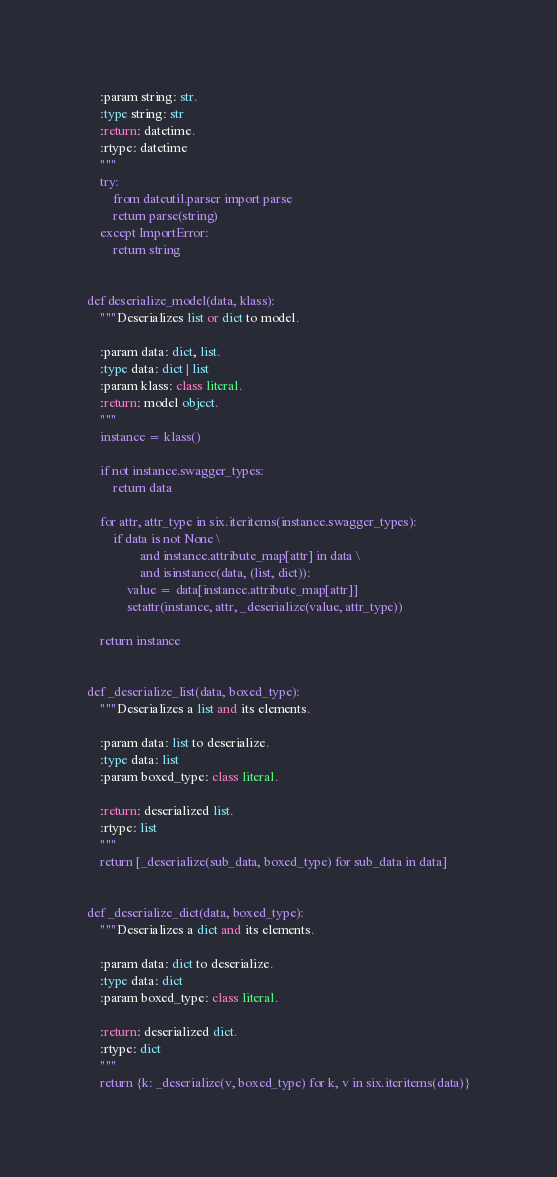<code> <loc_0><loc_0><loc_500><loc_500><_Python_>
    :param string: str.
    :type string: str
    :return: datetime.
    :rtype: datetime
    """
    try:
        from dateutil.parser import parse
        return parse(string)
    except ImportError:
        return string


def deserialize_model(data, klass):
    """Deserializes list or dict to model.

    :param data: dict, list.
    :type data: dict | list
    :param klass: class literal.
    :return: model object.
    """
    instance = klass()

    if not instance.swagger_types:
        return data

    for attr, attr_type in six.iteritems(instance.swagger_types):
        if data is not None \
                and instance.attribute_map[attr] in data \
                and isinstance(data, (list, dict)):
            value = data[instance.attribute_map[attr]]
            setattr(instance, attr, _deserialize(value, attr_type))

    return instance


def _deserialize_list(data, boxed_type):
    """Deserializes a list and its elements.

    :param data: list to deserialize.
    :type data: list
    :param boxed_type: class literal.

    :return: deserialized list.
    :rtype: list
    """
    return [_deserialize(sub_data, boxed_type) for sub_data in data]


def _deserialize_dict(data, boxed_type):
    """Deserializes a dict and its elements.

    :param data: dict to deserialize.
    :type data: dict
    :param boxed_type: class literal.

    :return: deserialized dict.
    :rtype: dict
    """
    return {k: _deserialize(v, boxed_type) for k, v in six.iteritems(data)}
</code> 